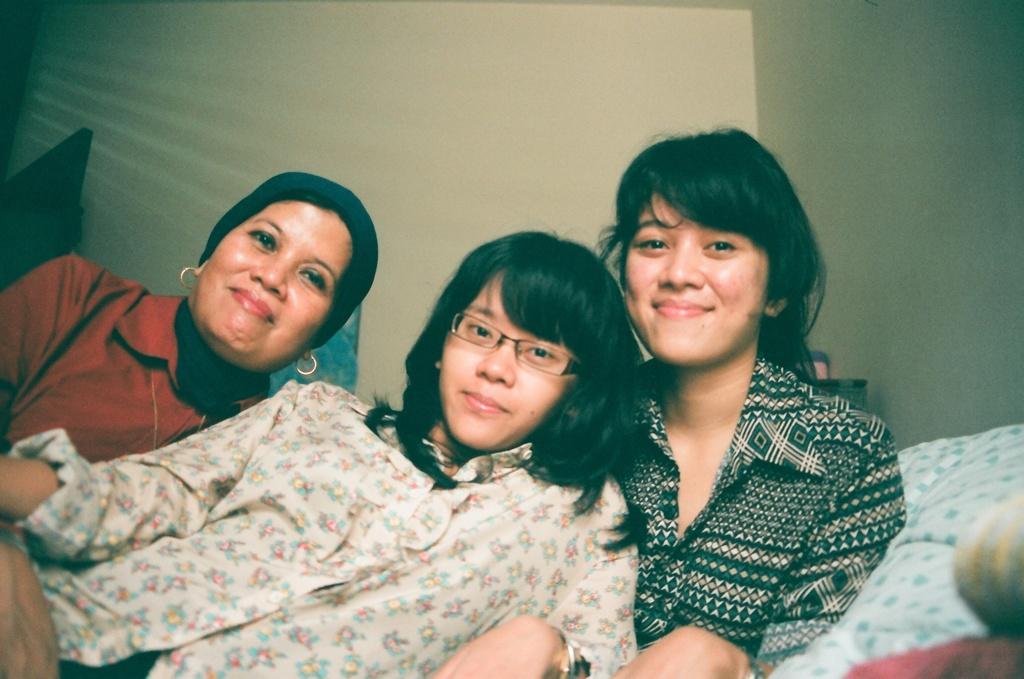Could you give a brief overview of what you see in this image? In the picture we can see three women are sitting together and leaning into each other and smiling and behind them we can see a wall. 